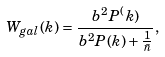<formula> <loc_0><loc_0><loc_500><loc_500>W _ { g a l } ( k ) = \frac { b ^ { 2 } P ^ { ( } k ) } { b ^ { 2 } P ( k ) + \frac { 1 } { \bar { n } } } ,</formula> 